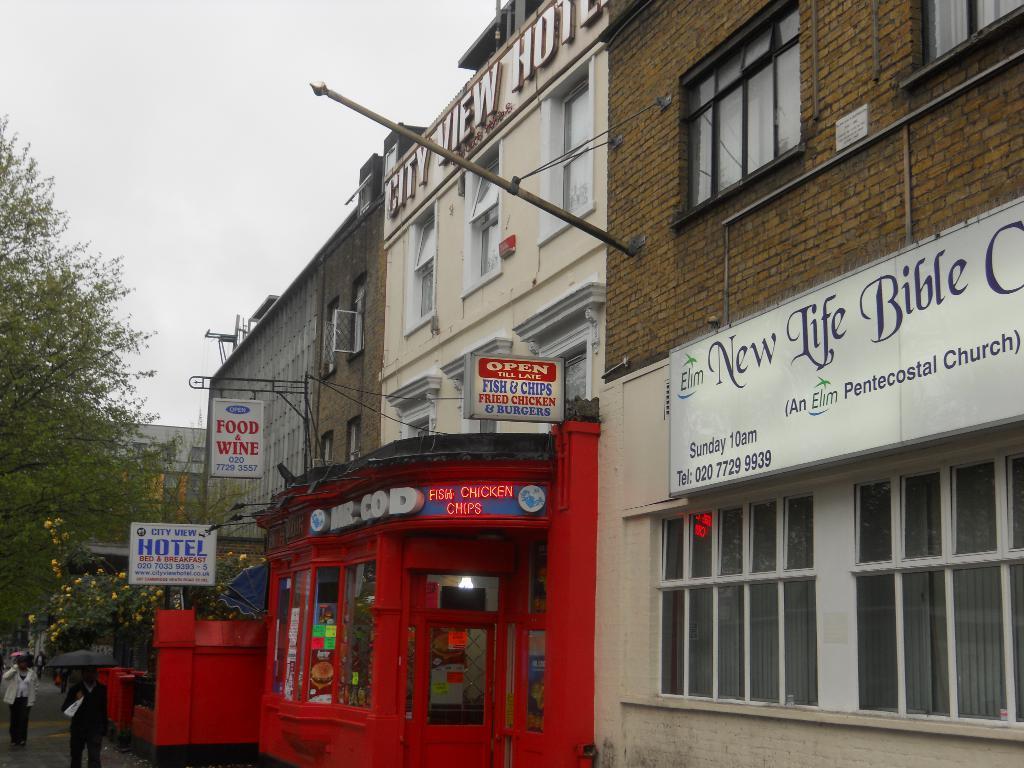In one or two sentences, can you explain what this image depicts? On the left side there are few persons walking on the road and among them a man is holding an umbrella in his hand and there are trees and plants with flowers. In the background there are buildings, hoardings, windows, poles, name boards on the wall, doors and clouds in the sky. Through the glass doors we can see lights and objects. 